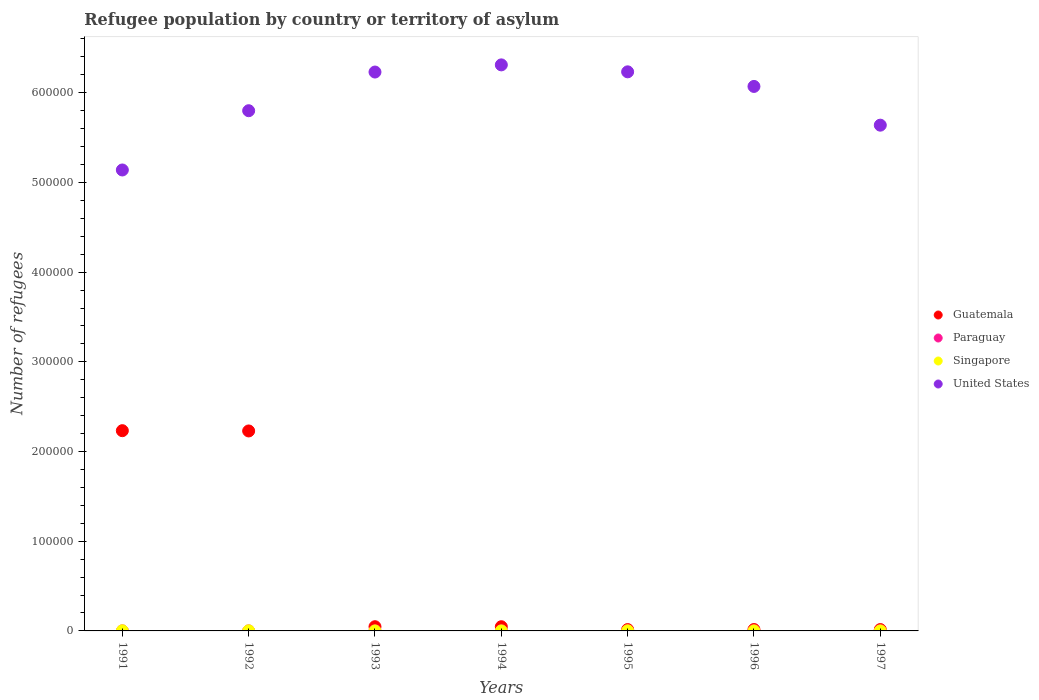What is the number of refugees in Singapore in 1995?
Offer a very short reply. 112. Across all years, what is the maximum number of refugees in Guatemala?
Keep it short and to the point. 2.23e+05. Across all years, what is the minimum number of refugees in Paraguay?
Provide a succinct answer. 45. What is the total number of refugees in Paraguay in the graph?
Offer a very short reply. 383. What is the difference between the number of refugees in Guatemala in 1993 and that in 1994?
Keep it short and to the point. 17. What is the difference between the number of refugees in Paraguay in 1991 and the number of refugees in United States in 1994?
Keep it short and to the point. -6.31e+05. What is the average number of refugees in Paraguay per year?
Ensure brevity in your answer.  54.71. In the year 1993, what is the difference between the number of refugees in Paraguay and number of refugees in Singapore?
Your response must be concise. 41. What is the ratio of the number of refugees in United States in 1994 to that in 1997?
Ensure brevity in your answer.  1.12. What is the difference between the highest and the second highest number of refugees in Guatemala?
Your response must be concise. 307. What is the difference between the highest and the lowest number of refugees in Guatemala?
Your answer should be very brief. 2.22e+05. Is the sum of the number of refugees in Guatemala in 1991 and 1996 greater than the maximum number of refugees in Singapore across all years?
Your answer should be very brief. Yes. Does the number of refugees in Singapore monotonically increase over the years?
Make the answer very short. No. Is the number of refugees in Paraguay strictly less than the number of refugees in Guatemala over the years?
Your answer should be compact. Yes. How many dotlines are there?
Offer a terse response. 4. How many years are there in the graph?
Provide a succinct answer. 7. Are the values on the major ticks of Y-axis written in scientific E-notation?
Offer a very short reply. No. Does the graph contain grids?
Ensure brevity in your answer.  No. Where does the legend appear in the graph?
Make the answer very short. Center right. What is the title of the graph?
Your answer should be very brief. Refugee population by country or territory of asylum. What is the label or title of the Y-axis?
Your answer should be very brief. Number of refugees. What is the Number of refugees in Guatemala in 1991?
Offer a very short reply. 2.23e+05. What is the Number of refugees in Singapore in 1991?
Your answer should be compact. 166. What is the Number of refugees in United States in 1991?
Keep it short and to the point. 5.14e+05. What is the Number of refugees in Guatemala in 1992?
Provide a succinct answer. 2.23e+05. What is the Number of refugees in Singapore in 1992?
Ensure brevity in your answer.  115. What is the Number of refugees of United States in 1992?
Your answer should be compact. 5.80e+05. What is the Number of refugees of Guatemala in 1993?
Provide a succinct answer. 4689. What is the Number of refugees in Singapore in 1993?
Your response must be concise. 11. What is the Number of refugees in United States in 1993?
Your response must be concise. 6.23e+05. What is the Number of refugees of Guatemala in 1994?
Keep it short and to the point. 4672. What is the Number of refugees in Paraguay in 1994?
Your response must be concise. 60. What is the Number of refugees of United States in 1994?
Your answer should be compact. 6.31e+05. What is the Number of refugees of Guatemala in 1995?
Provide a succinct answer. 1496. What is the Number of refugees of Paraguay in 1995?
Keep it short and to the point. 60. What is the Number of refugees of Singapore in 1995?
Offer a terse response. 112. What is the Number of refugees of United States in 1995?
Provide a succinct answer. 6.23e+05. What is the Number of refugees in Guatemala in 1996?
Your answer should be compact. 1564. What is the Number of refugees in Paraguay in 1996?
Your answer should be very brief. 53. What is the Number of refugees of Singapore in 1996?
Make the answer very short. 10. What is the Number of refugees in United States in 1996?
Make the answer very short. 6.07e+05. What is the Number of refugees of Guatemala in 1997?
Keep it short and to the point. 1508. What is the Number of refugees of Paraguay in 1997?
Make the answer very short. 47. What is the Number of refugees in United States in 1997?
Keep it short and to the point. 5.64e+05. Across all years, what is the maximum Number of refugees in Guatemala?
Ensure brevity in your answer.  2.23e+05. Across all years, what is the maximum Number of refugees of Singapore?
Your answer should be very brief. 166. Across all years, what is the maximum Number of refugees in United States?
Make the answer very short. 6.31e+05. Across all years, what is the minimum Number of refugees of Guatemala?
Make the answer very short. 1496. Across all years, what is the minimum Number of refugees of United States?
Provide a short and direct response. 5.14e+05. What is the total Number of refugees of Guatemala in the graph?
Make the answer very short. 4.60e+05. What is the total Number of refugees in Paraguay in the graph?
Provide a succinct answer. 383. What is the total Number of refugees in Singapore in the graph?
Ensure brevity in your answer.  431. What is the total Number of refugees in United States in the graph?
Your answer should be compact. 4.14e+06. What is the difference between the Number of refugees of Guatemala in 1991 and that in 1992?
Keep it short and to the point. 307. What is the difference between the Number of refugees of Paraguay in 1991 and that in 1992?
Your answer should be very brief. 21. What is the difference between the Number of refugees in United States in 1991 and that in 1992?
Offer a very short reply. -6.61e+04. What is the difference between the Number of refugees in Guatemala in 1991 and that in 1993?
Provide a succinct answer. 2.19e+05. What is the difference between the Number of refugees in Paraguay in 1991 and that in 1993?
Your answer should be very brief. 14. What is the difference between the Number of refugees in Singapore in 1991 and that in 1993?
Give a very brief answer. 155. What is the difference between the Number of refugees in United States in 1991 and that in 1993?
Offer a very short reply. -1.09e+05. What is the difference between the Number of refugees in Guatemala in 1991 and that in 1994?
Provide a short and direct response. 2.19e+05. What is the difference between the Number of refugees of Paraguay in 1991 and that in 1994?
Give a very brief answer. 6. What is the difference between the Number of refugees of Singapore in 1991 and that in 1994?
Your answer should be compact. 154. What is the difference between the Number of refugees in United States in 1991 and that in 1994?
Make the answer very short. -1.17e+05. What is the difference between the Number of refugees of Guatemala in 1991 and that in 1995?
Make the answer very short. 2.22e+05. What is the difference between the Number of refugees in Paraguay in 1991 and that in 1995?
Provide a succinct answer. 6. What is the difference between the Number of refugees in United States in 1991 and that in 1995?
Offer a terse response. -1.09e+05. What is the difference between the Number of refugees of Guatemala in 1991 and that in 1996?
Offer a very short reply. 2.22e+05. What is the difference between the Number of refugees in Singapore in 1991 and that in 1996?
Provide a succinct answer. 156. What is the difference between the Number of refugees of United States in 1991 and that in 1996?
Provide a short and direct response. -9.31e+04. What is the difference between the Number of refugees of Guatemala in 1991 and that in 1997?
Your answer should be compact. 2.22e+05. What is the difference between the Number of refugees in Singapore in 1991 and that in 1997?
Make the answer very short. 161. What is the difference between the Number of refugees in United States in 1991 and that in 1997?
Your answer should be very brief. -5.00e+04. What is the difference between the Number of refugees in Guatemala in 1992 and that in 1993?
Your answer should be compact. 2.18e+05. What is the difference between the Number of refugees of Paraguay in 1992 and that in 1993?
Your response must be concise. -7. What is the difference between the Number of refugees in Singapore in 1992 and that in 1993?
Give a very brief answer. 104. What is the difference between the Number of refugees of United States in 1992 and that in 1993?
Give a very brief answer. -4.31e+04. What is the difference between the Number of refugees of Guatemala in 1992 and that in 1994?
Your answer should be compact. 2.18e+05. What is the difference between the Number of refugees in Singapore in 1992 and that in 1994?
Give a very brief answer. 103. What is the difference between the Number of refugees in United States in 1992 and that in 1994?
Offer a very short reply. -5.11e+04. What is the difference between the Number of refugees of Guatemala in 1992 and that in 1995?
Make the answer very short. 2.21e+05. What is the difference between the Number of refugees of Paraguay in 1992 and that in 1995?
Give a very brief answer. -15. What is the difference between the Number of refugees of Singapore in 1992 and that in 1995?
Ensure brevity in your answer.  3. What is the difference between the Number of refugees in United States in 1992 and that in 1995?
Offer a terse response. -4.33e+04. What is the difference between the Number of refugees in Guatemala in 1992 and that in 1996?
Ensure brevity in your answer.  2.21e+05. What is the difference between the Number of refugees in Paraguay in 1992 and that in 1996?
Make the answer very short. -8. What is the difference between the Number of refugees of Singapore in 1992 and that in 1996?
Provide a short and direct response. 105. What is the difference between the Number of refugees in United States in 1992 and that in 1996?
Offer a terse response. -2.71e+04. What is the difference between the Number of refugees of Guatemala in 1992 and that in 1997?
Ensure brevity in your answer.  2.21e+05. What is the difference between the Number of refugees in Singapore in 1992 and that in 1997?
Your answer should be compact. 110. What is the difference between the Number of refugees in United States in 1992 and that in 1997?
Offer a very short reply. 1.61e+04. What is the difference between the Number of refugees in Guatemala in 1993 and that in 1994?
Give a very brief answer. 17. What is the difference between the Number of refugees of Paraguay in 1993 and that in 1994?
Your answer should be compact. -8. What is the difference between the Number of refugees of United States in 1993 and that in 1994?
Ensure brevity in your answer.  -7982. What is the difference between the Number of refugees of Guatemala in 1993 and that in 1995?
Your answer should be compact. 3193. What is the difference between the Number of refugees in Paraguay in 1993 and that in 1995?
Keep it short and to the point. -8. What is the difference between the Number of refugees of Singapore in 1993 and that in 1995?
Your answer should be compact. -101. What is the difference between the Number of refugees of United States in 1993 and that in 1995?
Offer a very short reply. -225. What is the difference between the Number of refugees of Guatemala in 1993 and that in 1996?
Make the answer very short. 3125. What is the difference between the Number of refugees of United States in 1993 and that in 1996?
Provide a succinct answer. 1.60e+04. What is the difference between the Number of refugees in Guatemala in 1993 and that in 1997?
Offer a very short reply. 3181. What is the difference between the Number of refugees of Paraguay in 1993 and that in 1997?
Keep it short and to the point. 5. What is the difference between the Number of refugees of United States in 1993 and that in 1997?
Your answer should be compact. 5.92e+04. What is the difference between the Number of refugees in Guatemala in 1994 and that in 1995?
Offer a terse response. 3176. What is the difference between the Number of refugees of Paraguay in 1994 and that in 1995?
Your answer should be compact. 0. What is the difference between the Number of refugees of Singapore in 1994 and that in 1995?
Your answer should be compact. -100. What is the difference between the Number of refugees in United States in 1994 and that in 1995?
Offer a terse response. 7757. What is the difference between the Number of refugees of Guatemala in 1994 and that in 1996?
Your response must be concise. 3108. What is the difference between the Number of refugees in Singapore in 1994 and that in 1996?
Provide a succinct answer. 2. What is the difference between the Number of refugees in United States in 1994 and that in 1996?
Offer a very short reply. 2.40e+04. What is the difference between the Number of refugees of Guatemala in 1994 and that in 1997?
Offer a terse response. 3164. What is the difference between the Number of refugees of United States in 1994 and that in 1997?
Give a very brief answer. 6.72e+04. What is the difference between the Number of refugees in Guatemala in 1995 and that in 1996?
Ensure brevity in your answer.  -68. What is the difference between the Number of refugees of Singapore in 1995 and that in 1996?
Keep it short and to the point. 102. What is the difference between the Number of refugees in United States in 1995 and that in 1996?
Ensure brevity in your answer.  1.63e+04. What is the difference between the Number of refugees of Guatemala in 1995 and that in 1997?
Make the answer very short. -12. What is the difference between the Number of refugees of Singapore in 1995 and that in 1997?
Ensure brevity in your answer.  107. What is the difference between the Number of refugees in United States in 1995 and that in 1997?
Ensure brevity in your answer.  5.95e+04. What is the difference between the Number of refugees of Paraguay in 1996 and that in 1997?
Keep it short and to the point. 6. What is the difference between the Number of refugees of Singapore in 1996 and that in 1997?
Make the answer very short. 5. What is the difference between the Number of refugees of United States in 1996 and that in 1997?
Provide a short and direct response. 4.32e+04. What is the difference between the Number of refugees of Guatemala in 1991 and the Number of refugees of Paraguay in 1992?
Make the answer very short. 2.23e+05. What is the difference between the Number of refugees of Guatemala in 1991 and the Number of refugees of Singapore in 1992?
Provide a succinct answer. 2.23e+05. What is the difference between the Number of refugees of Guatemala in 1991 and the Number of refugees of United States in 1992?
Keep it short and to the point. -3.57e+05. What is the difference between the Number of refugees in Paraguay in 1991 and the Number of refugees in Singapore in 1992?
Provide a succinct answer. -49. What is the difference between the Number of refugees of Paraguay in 1991 and the Number of refugees of United States in 1992?
Provide a short and direct response. -5.80e+05. What is the difference between the Number of refugees of Singapore in 1991 and the Number of refugees of United States in 1992?
Keep it short and to the point. -5.80e+05. What is the difference between the Number of refugees in Guatemala in 1991 and the Number of refugees in Paraguay in 1993?
Your answer should be compact. 2.23e+05. What is the difference between the Number of refugees in Guatemala in 1991 and the Number of refugees in Singapore in 1993?
Provide a succinct answer. 2.23e+05. What is the difference between the Number of refugees in Guatemala in 1991 and the Number of refugees in United States in 1993?
Your answer should be compact. -4.00e+05. What is the difference between the Number of refugees in Paraguay in 1991 and the Number of refugees in United States in 1993?
Ensure brevity in your answer.  -6.23e+05. What is the difference between the Number of refugees in Singapore in 1991 and the Number of refugees in United States in 1993?
Offer a terse response. -6.23e+05. What is the difference between the Number of refugees in Guatemala in 1991 and the Number of refugees in Paraguay in 1994?
Your answer should be compact. 2.23e+05. What is the difference between the Number of refugees of Guatemala in 1991 and the Number of refugees of Singapore in 1994?
Offer a terse response. 2.23e+05. What is the difference between the Number of refugees of Guatemala in 1991 and the Number of refugees of United States in 1994?
Offer a terse response. -4.08e+05. What is the difference between the Number of refugees of Paraguay in 1991 and the Number of refugees of Singapore in 1994?
Your answer should be very brief. 54. What is the difference between the Number of refugees of Paraguay in 1991 and the Number of refugees of United States in 1994?
Make the answer very short. -6.31e+05. What is the difference between the Number of refugees in Singapore in 1991 and the Number of refugees in United States in 1994?
Give a very brief answer. -6.31e+05. What is the difference between the Number of refugees in Guatemala in 1991 and the Number of refugees in Paraguay in 1995?
Offer a terse response. 2.23e+05. What is the difference between the Number of refugees in Guatemala in 1991 and the Number of refugees in Singapore in 1995?
Keep it short and to the point. 2.23e+05. What is the difference between the Number of refugees of Guatemala in 1991 and the Number of refugees of United States in 1995?
Ensure brevity in your answer.  -4.00e+05. What is the difference between the Number of refugees in Paraguay in 1991 and the Number of refugees in Singapore in 1995?
Ensure brevity in your answer.  -46. What is the difference between the Number of refugees of Paraguay in 1991 and the Number of refugees of United States in 1995?
Ensure brevity in your answer.  -6.23e+05. What is the difference between the Number of refugees of Singapore in 1991 and the Number of refugees of United States in 1995?
Your answer should be very brief. -6.23e+05. What is the difference between the Number of refugees in Guatemala in 1991 and the Number of refugees in Paraguay in 1996?
Provide a short and direct response. 2.23e+05. What is the difference between the Number of refugees of Guatemala in 1991 and the Number of refugees of Singapore in 1996?
Provide a succinct answer. 2.23e+05. What is the difference between the Number of refugees of Guatemala in 1991 and the Number of refugees of United States in 1996?
Offer a very short reply. -3.84e+05. What is the difference between the Number of refugees of Paraguay in 1991 and the Number of refugees of United States in 1996?
Your answer should be very brief. -6.07e+05. What is the difference between the Number of refugees in Singapore in 1991 and the Number of refugees in United States in 1996?
Your response must be concise. -6.07e+05. What is the difference between the Number of refugees in Guatemala in 1991 and the Number of refugees in Paraguay in 1997?
Keep it short and to the point. 2.23e+05. What is the difference between the Number of refugees in Guatemala in 1991 and the Number of refugees in Singapore in 1997?
Your answer should be very brief. 2.23e+05. What is the difference between the Number of refugees of Guatemala in 1991 and the Number of refugees of United States in 1997?
Offer a very short reply. -3.41e+05. What is the difference between the Number of refugees in Paraguay in 1991 and the Number of refugees in Singapore in 1997?
Your answer should be compact. 61. What is the difference between the Number of refugees of Paraguay in 1991 and the Number of refugees of United States in 1997?
Offer a terse response. -5.64e+05. What is the difference between the Number of refugees in Singapore in 1991 and the Number of refugees in United States in 1997?
Offer a terse response. -5.64e+05. What is the difference between the Number of refugees in Guatemala in 1992 and the Number of refugees in Paraguay in 1993?
Keep it short and to the point. 2.23e+05. What is the difference between the Number of refugees of Guatemala in 1992 and the Number of refugees of Singapore in 1993?
Offer a terse response. 2.23e+05. What is the difference between the Number of refugees in Guatemala in 1992 and the Number of refugees in United States in 1993?
Your response must be concise. -4.00e+05. What is the difference between the Number of refugees of Paraguay in 1992 and the Number of refugees of United States in 1993?
Offer a terse response. -6.23e+05. What is the difference between the Number of refugees in Singapore in 1992 and the Number of refugees in United States in 1993?
Your answer should be very brief. -6.23e+05. What is the difference between the Number of refugees in Guatemala in 1992 and the Number of refugees in Paraguay in 1994?
Your answer should be very brief. 2.23e+05. What is the difference between the Number of refugees of Guatemala in 1992 and the Number of refugees of Singapore in 1994?
Give a very brief answer. 2.23e+05. What is the difference between the Number of refugees of Guatemala in 1992 and the Number of refugees of United States in 1994?
Keep it short and to the point. -4.08e+05. What is the difference between the Number of refugees of Paraguay in 1992 and the Number of refugees of Singapore in 1994?
Your answer should be very brief. 33. What is the difference between the Number of refugees in Paraguay in 1992 and the Number of refugees in United States in 1994?
Your response must be concise. -6.31e+05. What is the difference between the Number of refugees in Singapore in 1992 and the Number of refugees in United States in 1994?
Keep it short and to the point. -6.31e+05. What is the difference between the Number of refugees of Guatemala in 1992 and the Number of refugees of Paraguay in 1995?
Keep it short and to the point. 2.23e+05. What is the difference between the Number of refugees of Guatemala in 1992 and the Number of refugees of Singapore in 1995?
Provide a succinct answer. 2.23e+05. What is the difference between the Number of refugees of Guatemala in 1992 and the Number of refugees of United States in 1995?
Your response must be concise. -4.00e+05. What is the difference between the Number of refugees in Paraguay in 1992 and the Number of refugees in Singapore in 1995?
Keep it short and to the point. -67. What is the difference between the Number of refugees in Paraguay in 1992 and the Number of refugees in United States in 1995?
Make the answer very short. -6.23e+05. What is the difference between the Number of refugees in Singapore in 1992 and the Number of refugees in United States in 1995?
Make the answer very short. -6.23e+05. What is the difference between the Number of refugees in Guatemala in 1992 and the Number of refugees in Paraguay in 1996?
Keep it short and to the point. 2.23e+05. What is the difference between the Number of refugees in Guatemala in 1992 and the Number of refugees in Singapore in 1996?
Offer a terse response. 2.23e+05. What is the difference between the Number of refugees in Guatemala in 1992 and the Number of refugees in United States in 1996?
Offer a very short reply. -3.84e+05. What is the difference between the Number of refugees of Paraguay in 1992 and the Number of refugees of United States in 1996?
Ensure brevity in your answer.  -6.07e+05. What is the difference between the Number of refugees in Singapore in 1992 and the Number of refugees in United States in 1996?
Give a very brief answer. -6.07e+05. What is the difference between the Number of refugees of Guatemala in 1992 and the Number of refugees of Paraguay in 1997?
Ensure brevity in your answer.  2.23e+05. What is the difference between the Number of refugees of Guatemala in 1992 and the Number of refugees of Singapore in 1997?
Your response must be concise. 2.23e+05. What is the difference between the Number of refugees of Guatemala in 1992 and the Number of refugees of United States in 1997?
Provide a succinct answer. -3.41e+05. What is the difference between the Number of refugees in Paraguay in 1992 and the Number of refugees in United States in 1997?
Offer a very short reply. -5.64e+05. What is the difference between the Number of refugees of Singapore in 1992 and the Number of refugees of United States in 1997?
Your response must be concise. -5.64e+05. What is the difference between the Number of refugees in Guatemala in 1993 and the Number of refugees in Paraguay in 1994?
Offer a very short reply. 4629. What is the difference between the Number of refugees in Guatemala in 1993 and the Number of refugees in Singapore in 1994?
Your answer should be very brief. 4677. What is the difference between the Number of refugees of Guatemala in 1993 and the Number of refugees of United States in 1994?
Keep it short and to the point. -6.26e+05. What is the difference between the Number of refugees of Paraguay in 1993 and the Number of refugees of United States in 1994?
Make the answer very short. -6.31e+05. What is the difference between the Number of refugees of Singapore in 1993 and the Number of refugees of United States in 1994?
Your response must be concise. -6.31e+05. What is the difference between the Number of refugees in Guatemala in 1993 and the Number of refugees in Paraguay in 1995?
Your answer should be very brief. 4629. What is the difference between the Number of refugees in Guatemala in 1993 and the Number of refugees in Singapore in 1995?
Offer a terse response. 4577. What is the difference between the Number of refugees in Guatemala in 1993 and the Number of refugees in United States in 1995?
Provide a succinct answer. -6.19e+05. What is the difference between the Number of refugees in Paraguay in 1993 and the Number of refugees in Singapore in 1995?
Provide a short and direct response. -60. What is the difference between the Number of refugees in Paraguay in 1993 and the Number of refugees in United States in 1995?
Your response must be concise. -6.23e+05. What is the difference between the Number of refugees of Singapore in 1993 and the Number of refugees of United States in 1995?
Keep it short and to the point. -6.23e+05. What is the difference between the Number of refugees of Guatemala in 1993 and the Number of refugees of Paraguay in 1996?
Make the answer very short. 4636. What is the difference between the Number of refugees of Guatemala in 1993 and the Number of refugees of Singapore in 1996?
Your response must be concise. 4679. What is the difference between the Number of refugees of Guatemala in 1993 and the Number of refugees of United States in 1996?
Your answer should be very brief. -6.02e+05. What is the difference between the Number of refugees of Paraguay in 1993 and the Number of refugees of Singapore in 1996?
Make the answer very short. 42. What is the difference between the Number of refugees in Paraguay in 1993 and the Number of refugees in United States in 1996?
Your answer should be compact. -6.07e+05. What is the difference between the Number of refugees of Singapore in 1993 and the Number of refugees of United States in 1996?
Make the answer very short. -6.07e+05. What is the difference between the Number of refugees of Guatemala in 1993 and the Number of refugees of Paraguay in 1997?
Provide a succinct answer. 4642. What is the difference between the Number of refugees in Guatemala in 1993 and the Number of refugees in Singapore in 1997?
Make the answer very short. 4684. What is the difference between the Number of refugees in Guatemala in 1993 and the Number of refugees in United States in 1997?
Make the answer very short. -5.59e+05. What is the difference between the Number of refugees in Paraguay in 1993 and the Number of refugees in United States in 1997?
Your answer should be compact. -5.64e+05. What is the difference between the Number of refugees of Singapore in 1993 and the Number of refugees of United States in 1997?
Keep it short and to the point. -5.64e+05. What is the difference between the Number of refugees in Guatemala in 1994 and the Number of refugees in Paraguay in 1995?
Give a very brief answer. 4612. What is the difference between the Number of refugees in Guatemala in 1994 and the Number of refugees in Singapore in 1995?
Ensure brevity in your answer.  4560. What is the difference between the Number of refugees in Guatemala in 1994 and the Number of refugees in United States in 1995?
Make the answer very short. -6.19e+05. What is the difference between the Number of refugees in Paraguay in 1994 and the Number of refugees in Singapore in 1995?
Offer a terse response. -52. What is the difference between the Number of refugees of Paraguay in 1994 and the Number of refugees of United States in 1995?
Give a very brief answer. -6.23e+05. What is the difference between the Number of refugees in Singapore in 1994 and the Number of refugees in United States in 1995?
Your answer should be very brief. -6.23e+05. What is the difference between the Number of refugees in Guatemala in 1994 and the Number of refugees in Paraguay in 1996?
Keep it short and to the point. 4619. What is the difference between the Number of refugees in Guatemala in 1994 and the Number of refugees in Singapore in 1996?
Make the answer very short. 4662. What is the difference between the Number of refugees in Guatemala in 1994 and the Number of refugees in United States in 1996?
Provide a short and direct response. -6.02e+05. What is the difference between the Number of refugees in Paraguay in 1994 and the Number of refugees in Singapore in 1996?
Make the answer very short. 50. What is the difference between the Number of refugees of Paraguay in 1994 and the Number of refugees of United States in 1996?
Give a very brief answer. -6.07e+05. What is the difference between the Number of refugees in Singapore in 1994 and the Number of refugees in United States in 1996?
Keep it short and to the point. -6.07e+05. What is the difference between the Number of refugees of Guatemala in 1994 and the Number of refugees of Paraguay in 1997?
Your answer should be compact. 4625. What is the difference between the Number of refugees in Guatemala in 1994 and the Number of refugees in Singapore in 1997?
Make the answer very short. 4667. What is the difference between the Number of refugees of Guatemala in 1994 and the Number of refugees of United States in 1997?
Offer a very short reply. -5.59e+05. What is the difference between the Number of refugees in Paraguay in 1994 and the Number of refugees in Singapore in 1997?
Your response must be concise. 55. What is the difference between the Number of refugees in Paraguay in 1994 and the Number of refugees in United States in 1997?
Your answer should be very brief. -5.64e+05. What is the difference between the Number of refugees in Singapore in 1994 and the Number of refugees in United States in 1997?
Provide a short and direct response. -5.64e+05. What is the difference between the Number of refugees of Guatemala in 1995 and the Number of refugees of Paraguay in 1996?
Give a very brief answer. 1443. What is the difference between the Number of refugees in Guatemala in 1995 and the Number of refugees in Singapore in 1996?
Your response must be concise. 1486. What is the difference between the Number of refugees of Guatemala in 1995 and the Number of refugees of United States in 1996?
Your answer should be compact. -6.06e+05. What is the difference between the Number of refugees of Paraguay in 1995 and the Number of refugees of United States in 1996?
Offer a very short reply. -6.07e+05. What is the difference between the Number of refugees of Singapore in 1995 and the Number of refugees of United States in 1996?
Your answer should be very brief. -6.07e+05. What is the difference between the Number of refugees of Guatemala in 1995 and the Number of refugees of Paraguay in 1997?
Provide a short and direct response. 1449. What is the difference between the Number of refugees of Guatemala in 1995 and the Number of refugees of Singapore in 1997?
Your response must be concise. 1491. What is the difference between the Number of refugees in Guatemala in 1995 and the Number of refugees in United States in 1997?
Your answer should be compact. -5.62e+05. What is the difference between the Number of refugees in Paraguay in 1995 and the Number of refugees in Singapore in 1997?
Ensure brevity in your answer.  55. What is the difference between the Number of refugees of Paraguay in 1995 and the Number of refugees of United States in 1997?
Provide a short and direct response. -5.64e+05. What is the difference between the Number of refugees of Singapore in 1995 and the Number of refugees of United States in 1997?
Offer a very short reply. -5.64e+05. What is the difference between the Number of refugees of Guatemala in 1996 and the Number of refugees of Paraguay in 1997?
Keep it short and to the point. 1517. What is the difference between the Number of refugees in Guatemala in 1996 and the Number of refugees in Singapore in 1997?
Provide a succinct answer. 1559. What is the difference between the Number of refugees of Guatemala in 1996 and the Number of refugees of United States in 1997?
Keep it short and to the point. -5.62e+05. What is the difference between the Number of refugees of Paraguay in 1996 and the Number of refugees of Singapore in 1997?
Provide a succinct answer. 48. What is the difference between the Number of refugees in Paraguay in 1996 and the Number of refugees in United States in 1997?
Make the answer very short. -5.64e+05. What is the difference between the Number of refugees of Singapore in 1996 and the Number of refugees of United States in 1997?
Offer a terse response. -5.64e+05. What is the average Number of refugees of Guatemala per year?
Make the answer very short. 6.57e+04. What is the average Number of refugees of Paraguay per year?
Keep it short and to the point. 54.71. What is the average Number of refugees of Singapore per year?
Offer a terse response. 61.57. What is the average Number of refugees in United States per year?
Give a very brief answer. 5.92e+05. In the year 1991, what is the difference between the Number of refugees in Guatemala and Number of refugees in Paraguay?
Your response must be concise. 2.23e+05. In the year 1991, what is the difference between the Number of refugees in Guatemala and Number of refugees in Singapore?
Your answer should be compact. 2.23e+05. In the year 1991, what is the difference between the Number of refugees in Guatemala and Number of refugees in United States?
Your response must be concise. -2.91e+05. In the year 1991, what is the difference between the Number of refugees in Paraguay and Number of refugees in Singapore?
Offer a very short reply. -100. In the year 1991, what is the difference between the Number of refugees in Paraguay and Number of refugees in United States?
Ensure brevity in your answer.  -5.14e+05. In the year 1991, what is the difference between the Number of refugees of Singapore and Number of refugees of United States?
Offer a very short reply. -5.14e+05. In the year 1992, what is the difference between the Number of refugees in Guatemala and Number of refugees in Paraguay?
Offer a very short reply. 2.23e+05. In the year 1992, what is the difference between the Number of refugees in Guatemala and Number of refugees in Singapore?
Give a very brief answer. 2.23e+05. In the year 1992, what is the difference between the Number of refugees in Guatemala and Number of refugees in United States?
Make the answer very short. -3.57e+05. In the year 1992, what is the difference between the Number of refugees of Paraguay and Number of refugees of Singapore?
Ensure brevity in your answer.  -70. In the year 1992, what is the difference between the Number of refugees of Paraguay and Number of refugees of United States?
Provide a short and direct response. -5.80e+05. In the year 1992, what is the difference between the Number of refugees in Singapore and Number of refugees in United States?
Offer a very short reply. -5.80e+05. In the year 1993, what is the difference between the Number of refugees in Guatemala and Number of refugees in Paraguay?
Your answer should be very brief. 4637. In the year 1993, what is the difference between the Number of refugees in Guatemala and Number of refugees in Singapore?
Offer a very short reply. 4678. In the year 1993, what is the difference between the Number of refugees in Guatemala and Number of refugees in United States?
Your response must be concise. -6.18e+05. In the year 1993, what is the difference between the Number of refugees in Paraguay and Number of refugees in Singapore?
Provide a short and direct response. 41. In the year 1993, what is the difference between the Number of refugees of Paraguay and Number of refugees of United States?
Provide a succinct answer. -6.23e+05. In the year 1993, what is the difference between the Number of refugees in Singapore and Number of refugees in United States?
Provide a succinct answer. -6.23e+05. In the year 1994, what is the difference between the Number of refugees in Guatemala and Number of refugees in Paraguay?
Your answer should be very brief. 4612. In the year 1994, what is the difference between the Number of refugees of Guatemala and Number of refugees of Singapore?
Provide a succinct answer. 4660. In the year 1994, what is the difference between the Number of refugees in Guatemala and Number of refugees in United States?
Make the answer very short. -6.26e+05. In the year 1994, what is the difference between the Number of refugees in Paraguay and Number of refugees in United States?
Offer a very short reply. -6.31e+05. In the year 1994, what is the difference between the Number of refugees in Singapore and Number of refugees in United States?
Ensure brevity in your answer.  -6.31e+05. In the year 1995, what is the difference between the Number of refugees of Guatemala and Number of refugees of Paraguay?
Provide a succinct answer. 1436. In the year 1995, what is the difference between the Number of refugees of Guatemala and Number of refugees of Singapore?
Provide a succinct answer. 1384. In the year 1995, what is the difference between the Number of refugees of Guatemala and Number of refugees of United States?
Make the answer very short. -6.22e+05. In the year 1995, what is the difference between the Number of refugees of Paraguay and Number of refugees of Singapore?
Ensure brevity in your answer.  -52. In the year 1995, what is the difference between the Number of refugees in Paraguay and Number of refugees in United States?
Offer a very short reply. -6.23e+05. In the year 1995, what is the difference between the Number of refugees of Singapore and Number of refugees of United States?
Ensure brevity in your answer.  -6.23e+05. In the year 1996, what is the difference between the Number of refugees of Guatemala and Number of refugees of Paraguay?
Give a very brief answer. 1511. In the year 1996, what is the difference between the Number of refugees in Guatemala and Number of refugees in Singapore?
Make the answer very short. 1554. In the year 1996, what is the difference between the Number of refugees of Guatemala and Number of refugees of United States?
Provide a short and direct response. -6.05e+05. In the year 1996, what is the difference between the Number of refugees of Paraguay and Number of refugees of United States?
Your response must be concise. -6.07e+05. In the year 1996, what is the difference between the Number of refugees of Singapore and Number of refugees of United States?
Ensure brevity in your answer.  -6.07e+05. In the year 1997, what is the difference between the Number of refugees of Guatemala and Number of refugees of Paraguay?
Keep it short and to the point. 1461. In the year 1997, what is the difference between the Number of refugees of Guatemala and Number of refugees of Singapore?
Your response must be concise. 1503. In the year 1997, what is the difference between the Number of refugees of Guatemala and Number of refugees of United States?
Ensure brevity in your answer.  -5.62e+05. In the year 1997, what is the difference between the Number of refugees in Paraguay and Number of refugees in United States?
Provide a succinct answer. -5.64e+05. In the year 1997, what is the difference between the Number of refugees of Singapore and Number of refugees of United States?
Provide a succinct answer. -5.64e+05. What is the ratio of the Number of refugees in Guatemala in 1991 to that in 1992?
Ensure brevity in your answer.  1. What is the ratio of the Number of refugees in Paraguay in 1991 to that in 1992?
Your answer should be compact. 1.47. What is the ratio of the Number of refugees of Singapore in 1991 to that in 1992?
Your answer should be very brief. 1.44. What is the ratio of the Number of refugees of United States in 1991 to that in 1992?
Provide a short and direct response. 0.89. What is the ratio of the Number of refugees in Guatemala in 1991 to that in 1993?
Your answer should be very brief. 47.61. What is the ratio of the Number of refugees of Paraguay in 1991 to that in 1993?
Provide a short and direct response. 1.27. What is the ratio of the Number of refugees in Singapore in 1991 to that in 1993?
Your answer should be very brief. 15.09. What is the ratio of the Number of refugees of United States in 1991 to that in 1993?
Ensure brevity in your answer.  0.82. What is the ratio of the Number of refugees in Guatemala in 1991 to that in 1994?
Give a very brief answer. 47.78. What is the ratio of the Number of refugees in Singapore in 1991 to that in 1994?
Keep it short and to the point. 13.83. What is the ratio of the Number of refugees of United States in 1991 to that in 1994?
Your answer should be very brief. 0.81. What is the ratio of the Number of refugees in Guatemala in 1991 to that in 1995?
Ensure brevity in your answer.  149.22. What is the ratio of the Number of refugees in Singapore in 1991 to that in 1995?
Provide a short and direct response. 1.48. What is the ratio of the Number of refugees of United States in 1991 to that in 1995?
Your answer should be very brief. 0.82. What is the ratio of the Number of refugees of Guatemala in 1991 to that in 1996?
Offer a terse response. 142.73. What is the ratio of the Number of refugees in Paraguay in 1991 to that in 1996?
Give a very brief answer. 1.25. What is the ratio of the Number of refugees in Singapore in 1991 to that in 1996?
Offer a terse response. 16.6. What is the ratio of the Number of refugees in United States in 1991 to that in 1996?
Give a very brief answer. 0.85. What is the ratio of the Number of refugees of Guatemala in 1991 to that in 1997?
Offer a very short reply. 148.03. What is the ratio of the Number of refugees in Paraguay in 1991 to that in 1997?
Your answer should be compact. 1.4. What is the ratio of the Number of refugees of Singapore in 1991 to that in 1997?
Ensure brevity in your answer.  33.2. What is the ratio of the Number of refugees in United States in 1991 to that in 1997?
Keep it short and to the point. 0.91. What is the ratio of the Number of refugees in Guatemala in 1992 to that in 1993?
Your answer should be very brief. 47.54. What is the ratio of the Number of refugees of Paraguay in 1992 to that in 1993?
Provide a succinct answer. 0.87. What is the ratio of the Number of refugees in Singapore in 1992 to that in 1993?
Keep it short and to the point. 10.45. What is the ratio of the Number of refugees in United States in 1992 to that in 1993?
Offer a very short reply. 0.93. What is the ratio of the Number of refugees in Guatemala in 1992 to that in 1994?
Provide a succinct answer. 47.72. What is the ratio of the Number of refugees of Singapore in 1992 to that in 1994?
Make the answer very short. 9.58. What is the ratio of the Number of refugees of United States in 1992 to that in 1994?
Your answer should be compact. 0.92. What is the ratio of the Number of refugees in Guatemala in 1992 to that in 1995?
Offer a very short reply. 149.02. What is the ratio of the Number of refugees of Paraguay in 1992 to that in 1995?
Provide a succinct answer. 0.75. What is the ratio of the Number of refugees in Singapore in 1992 to that in 1995?
Your answer should be very brief. 1.03. What is the ratio of the Number of refugees of United States in 1992 to that in 1995?
Your answer should be very brief. 0.93. What is the ratio of the Number of refugees in Guatemala in 1992 to that in 1996?
Ensure brevity in your answer.  142.54. What is the ratio of the Number of refugees in Paraguay in 1992 to that in 1996?
Your answer should be very brief. 0.85. What is the ratio of the Number of refugees in Singapore in 1992 to that in 1996?
Your response must be concise. 11.5. What is the ratio of the Number of refugees of United States in 1992 to that in 1996?
Your response must be concise. 0.96. What is the ratio of the Number of refugees in Guatemala in 1992 to that in 1997?
Your response must be concise. 147.83. What is the ratio of the Number of refugees of Paraguay in 1992 to that in 1997?
Make the answer very short. 0.96. What is the ratio of the Number of refugees of United States in 1992 to that in 1997?
Your response must be concise. 1.03. What is the ratio of the Number of refugees of Guatemala in 1993 to that in 1994?
Your response must be concise. 1. What is the ratio of the Number of refugees of Paraguay in 1993 to that in 1994?
Give a very brief answer. 0.87. What is the ratio of the Number of refugees of Singapore in 1993 to that in 1994?
Your answer should be very brief. 0.92. What is the ratio of the Number of refugees in United States in 1993 to that in 1994?
Your answer should be very brief. 0.99. What is the ratio of the Number of refugees in Guatemala in 1993 to that in 1995?
Offer a very short reply. 3.13. What is the ratio of the Number of refugees in Paraguay in 1993 to that in 1995?
Keep it short and to the point. 0.87. What is the ratio of the Number of refugees in Singapore in 1993 to that in 1995?
Provide a short and direct response. 0.1. What is the ratio of the Number of refugees of Guatemala in 1993 to that in 1996?
Offer a very short reply. 3. What is the ratio of the Number of refugees in Paraguay in 1993 to that in 1996?
Provide a short and direct response. 0.98. What is the ratio of the Number of refugees of Singapore in 1993 to that in 1996?
Your answer should be compact. 1.1. What is the ratio of the Number of refugees in United States in 1993 to that in 1996?
Provide a succinct answer. 1.03. What is the ratio of the Number of refugees in Guatemala in 1993 to that in 1997?
Your answer should be very brief. 3.11. What is the ratio of the Number of refugees in Paraguay in 1993 to that in 1997?
Your answer should be very brief. 1.11. What is the ratio of the Number of refugees in Singapore in 1993 to that in 1997?
Offer a very short reply. 2.2. What is the ratio of the Number of refugees of United States in 1993 to that in 1997?
Make the answer very short. 1.11. What is the ratio of the Number of refugees of Guatemala in 1994 to that in 1995?
Provide a succinct answer. 3.12. What is the ratio of the Number of refugees in Paraguay in 1994 to that in 1995?
Your response must be concise. 1. What is the ratio of the Number of refugees in Singapore in 1994 to that in 1995?
Provide a succinct answer. 0.11. What is the ratio of the Number of refugees in United States in 1994 to that in 1995?
Provide a succinct answer. 1.01. What is the ratio of the Number of refugees of Guatemala in 1994 to that in 1996?
Offer a very short reply. 2.99. What is the ratio of the Number of refugees of Paraguay in 1994 to that in 1996?
Provide a succinct answer. 1.13. What is the ratio of the Number of refugees in United States in 1994 to that in 1996?
Ensure brevity in your answer.  1.04. What is the ratio of the Number of refugees in Guatemala in 1994 to that in 1997?
Provide a succinct answer. 3.1. What is the ratio of the Number of refugees of Paraguay in 1994 to that in 1997?
Make the answer very short. 1.28. What is the ratio of the Number of refugees in United States in 1994 to that in 1997?
Your answer should be very brief. 1.12. What is the ratio of the Number of refugees of Guatemala in 1995 to that in 1996?
Offer a terse response. 0.96. What is the ratio of the Number of refugees of Paraguay in 1995 to that in 1996?
Offer a terse response. 1.13. What is the ratio of the Number of refugees in Singapore in 1995 to that in 1996?
Your answer should be very brief. 11.2. What is the ratio of the Number of refugees of United States in 1995 to that in 1996?
Your response must be concise. 1.03. What is the ratio of the Number of refugees in Paraguay in 1995 to that in 1997?
Offer a terse response. 1.28. What is the ratio of the Number of refugees in Singapore in 1995 to that in 1997?
Give a very brief answer. 22.4. What is the ratio of the Number of refugees of United States in 1995 to that in 1997?
Your response must be concise. 1.11. What is the ratio of the Number of refugees in Guatemala in 1996 to that in 1997?
Offer a very short reply. 1.04. What is the ratio of the Number of refugees of Paraguay in 1996 to that in 1997?
Keep it short and to the point. 1.13. What is the ratio of the Number of refugees in United States in 1996 to that in 1997?
Provide a short and direct response. 1.08. What is the difference between the highest and the second highest Number of refugees of Guatemala?
Keep it short and to the point. 307. What is the difference between the highest and the second highest Number of refugees of Paraguay?
Make the answer very short. 6. What is the difference between the highest and the second highest Number of refugees of Singapore?
Make the answer very short. 51. What is the difference between the highest and the second highest Number of refugees of United States?
Give a very brief answer. 7757. What is the difference between the highest and the lowest Number of refugees in Guatemala?
Ensure brevity in your answer.  2.22e+05. What is the difference between the highest and the lowest Number of refugees in Paraguay?
Give a very brief answer. 21. What is the difference between the highest and the lowest Number of refugees of Singapore?
Give a very brief answer. 161. What is the difference between the highest and the lowest Number of refugees in United States?
Your response must be concise. 1.17e+05. 